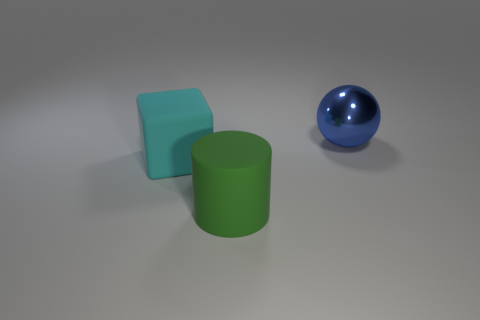Add 1 cyan things. How many objects exist? 4 Subtract all balls. How many objects are left? 2 Add 3 big matte cylinders. How many big matte cylinders are left? 4 Add 1 green rubber cylinders. How many green rubber cylinders exist? 2 Subtract 0 yellow spheres. How many objects are left? 3 Subtract all small red matte things. Subtract all green matte things. How many objects are left? 2 